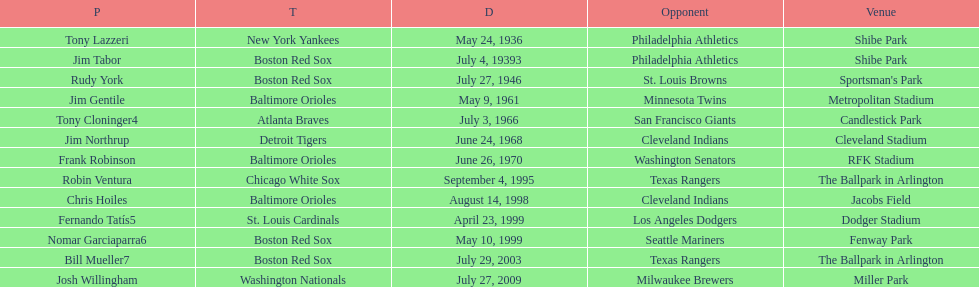On what date did the detroit tigers play the cleveland indians? June 24, 1968. 